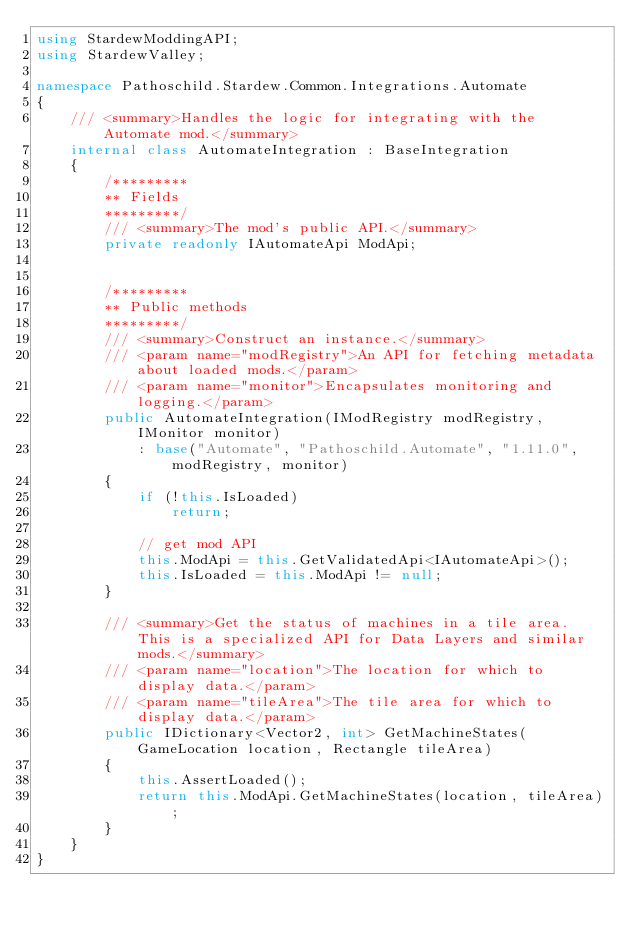<code> <loc_0><loc_0><loc_500><loc_500><_C#_>using StardewModdingAPI;
using StardewValley;

namespace Pathoschild.Stardew.Common.Integrations.Automate
{
    /// <summary>Handles the logic for integrating with the Automate mod.</summary>
    internal class AutomateIntegration : BaseIntegration
    {
        /*********
        ** Fields
        *********/
        /// <summary>The mod's public API.</summary>
        private readonly IAutomateApi ModApi;


        /*********
        ** Public methods
        *********/
        /// <summary>Construct an instance.</summary>
        /// <param name="modRegistry">An API for fetching metadata about loaded mods.</param>
        /// <param name="monitor">Encapsulates monitoring and logging.</param>
        public AutomateIntegration(IModRegistry modRegistry, IMonitor monitor)
            : base("Automate", "Pathoschild.Automate", "1.11.0", modRegistry, monitor)
        {
            if (!this.IsLoaded)
                return;

            // get mod API
            this.ModApi = this.GetValidatedApi<IAutomateApi>();
            this.IsLoaded = this.ModApi != null;
        }

        /// <summary>Get the status of machines in a tile area. This is a specialized API for Data Layers and similar mods.</summary>
        /// <param name="location">The location for which to display data.</param>
        /// <param name="tileArea">The tile area for which to display data.</param>
        public IDictionary<Vector2, int> GetMachineStates(GameLocation location, Rectangle tileArea)
        {
            this.AssertLoaded();
            return this.ModApi.GetMachineStates(location, tileArea);
        }
    }
}
</code> 